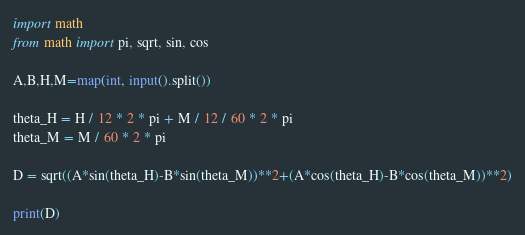Convert code to text. <code><loc_0><loc_0><loc_500><loc_500><_Python_>import math
from math import pi, sqrt, sin, cos

A,B,H,M=map(int, input().split())

theta_H = H / 12 * 2 * pi + M / 12 / 60 * 2 * pi
theta_M = M / 60 * 2 * pi

D = sqrt((A*sin(theta_H)-B*sin(theta_M))**2+(A*cos(theta_H)-B*cos(theta_M))**2)

print(D)</code> 